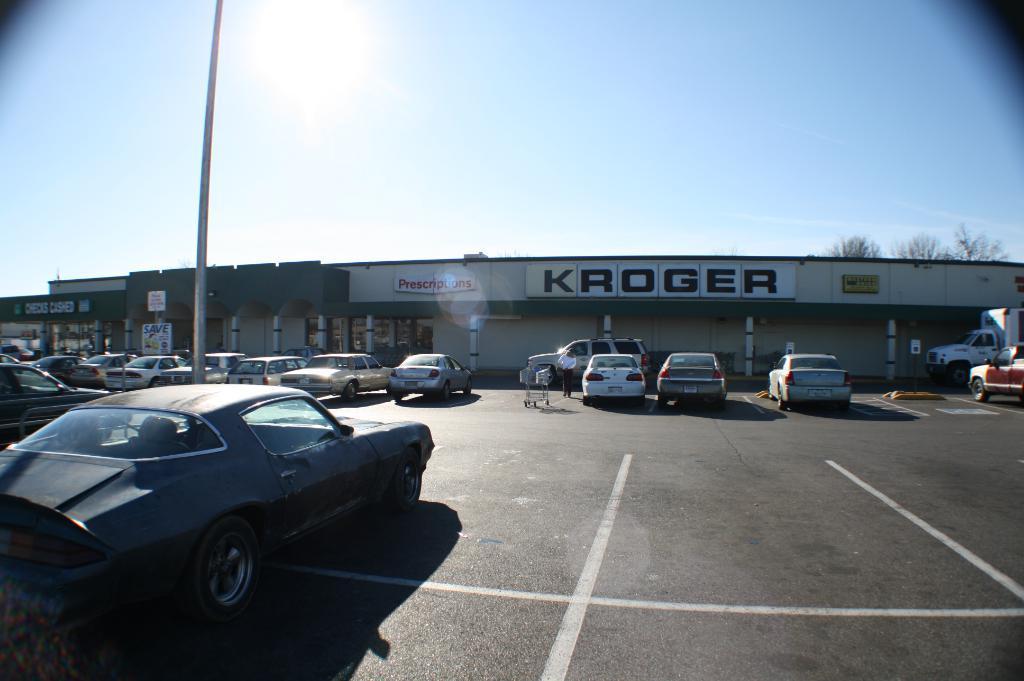How would you summarize this image in a sentence or two? In this image we can see cars on the road. There is a trolley and we can see a person. On the left there is a pole. In the background there is a building, trees and sky. 